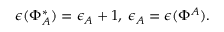<formula> <loc_0><loc_0><loc_500><loc_500>\epsilon ( \Phi _ { A } ^ { * } ) = \epsilon _ { A } + 1 , \, \epsilon _ { A } = \epsilon ( \Phi ^ { A } ) .</formula> 